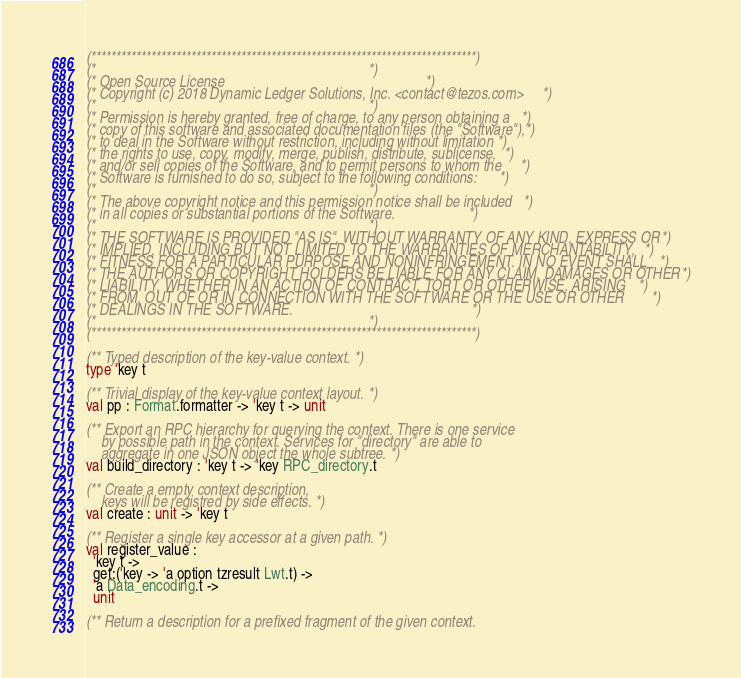Convert code to text. <code><loc_0><loc_0><loc_500><loc_500><_OCaml_>(*****************************************************************************)
(*                                                                           *)
(* Open Source License                                                       *)
(* Copyright (c) 2018 Dynamic Ledger Solutions, Inc. <contact@tezos.com>     *)
(*                                                                           *)
(* Permission is hereby granted, free of charge, to any person obtaining a   *)
(* copy of this software and associated documentation files (the "Software"),*)
(* to deal in the Software without restriction, including without limitation *)
(* the rights to use, copy, modify, merge, publish, distribute, sublicense,  *)
(* and/or sell copies of the Software, and to permit persons to whom the     *)
(* Software is furnished to do so, subject to the following conditions:      *)
(*                                                                           *)
(* The above copyright notice and this permission notice shall be included   *)
(* in all copies or substantial portions of the Software.                    *)
(*                                                                           *)
(* THE SOFTWARE IS PROVIDED "AS IS", WITHOUT WARRANTY OF ANY KIND, EXPRESS OR*)
(* IMPLIED, INCLUDING BUT NOT LIMITED TO THE WARRANTIES OF MERCHANTABILITY,  *)
(* FITNESS FOR A PARTICULAR PURPOSE AND NONINFRINGEMENT. IN NO EVENT SHALL   *)
(* THE AUTHORS OR COPYRIGHT HOLDERS BE LIABLE FOR ANY CLAIM, DAMAGES OR OTHER*)
(* LIABILITY, WHETHER IN AN ACTION OF CONTRACT, TORT OR OTHERWISE, ARISING   *)
(* FROM, OUT OF OR IN CONNECTION WITH THE SOFTWARE OR THE USE OR OTHER       *)
(* DEALINGS IN THE SOFTWARE.                                                 *)
(*                                                                           *)
(*****************************************************************************)

(** Typed description of the key-value context. *)
type 'key t

(** Trivial display of the key-value context layout. *)
val pp : Format.formatter -> 'key t -> unit

(** Export an RPC hierarchy for querying the context. There is one service
    by possible path in the context. Services for "directory" are able to
    aggregate in one JSON object the whole subtree. *)
val build_directory : 'key t -> 'key RPC_directory.t

(** Create a empty context description,
    keys will be registred by side effects. *)
val create : unit -> 'key t

(** Register a single key accessor at a given path. *)
val register_value :
  'key t ->
  get:('key -> 'a option tzresult Lwt.t) ->
  'a Data_encoding.t ->
  unit

(** Return a description for a prefixed fragment of the given context.</code> 